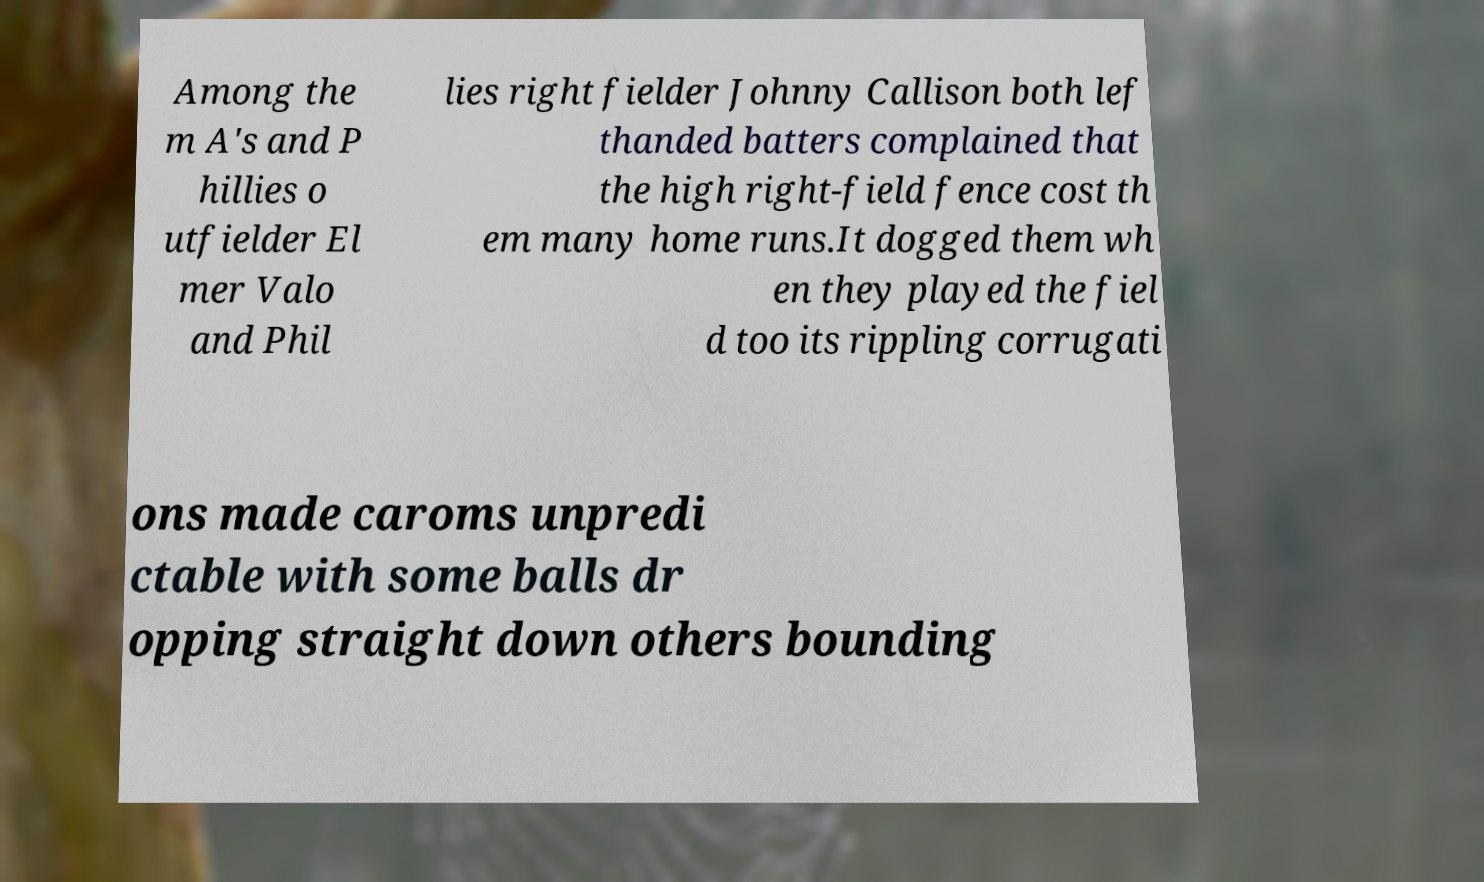Please identify and transcribe the text found in this image. Among the m A's and P hillies o utfielder El mer Valo and Phil lies right fielder Johnny Callison both lef thanded batters complained that the high right-field fence cost th em many home runs.It dogged them wh en they played the fiel d too its rippling corrugati ons made caroms unpredi ctable with some balls dr opping straight down others bounding 